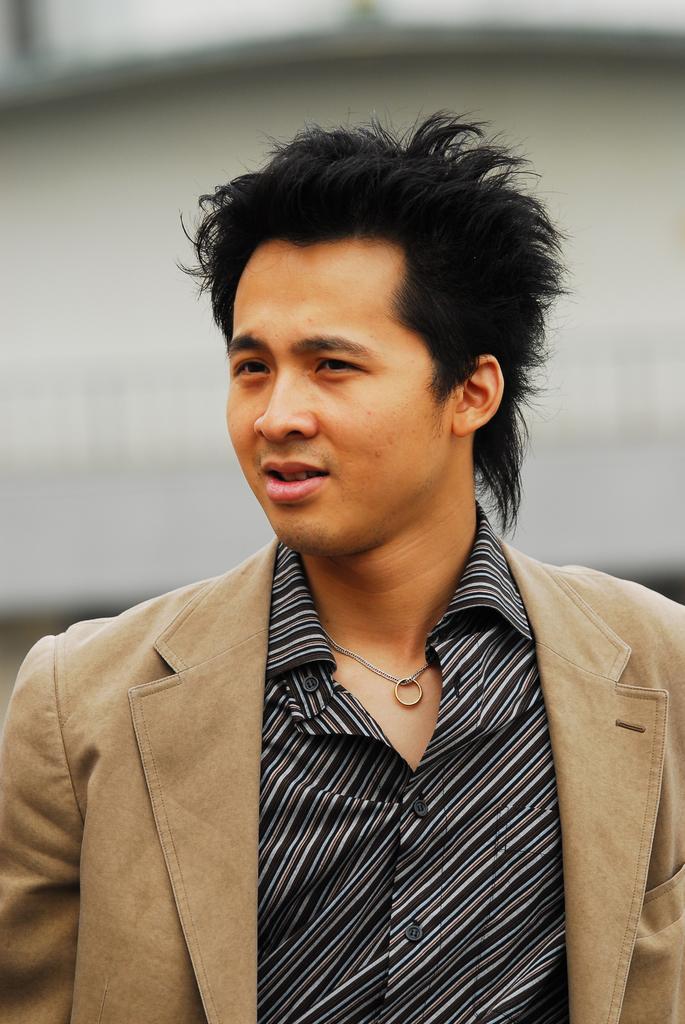How would you summarize this image in a sentence or two? In this image, we can see a man wearing chain with ring. In the background, there is a blur view. 